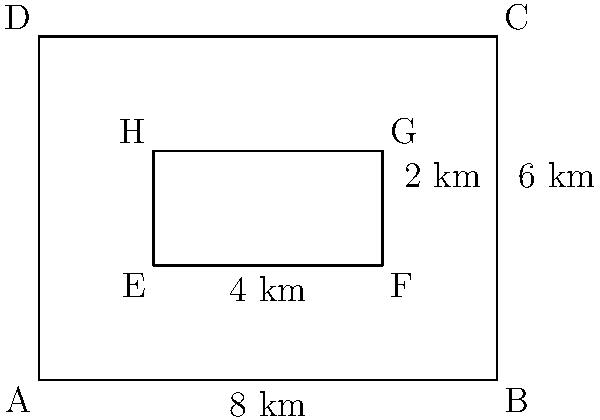As the alpha snow leopard, you need to calculate the area of your territory. The outer rectangle ABCD represents the entire region, while the inner rectangle EFGH represents a lake that is not part of your territory. If AB = 8 km, BC = 6 km, EF = 4 km, and FG = 2 km, what is the area of your territory in square kilometers? To find the area of the snow leopard's territory, we need to:

1. Calculate the area of the entire region (rectangle ABCD):
   Area of ABCD = $AB \times BC = 8 \text{ km} \times 6 \text{ km} = 48 \text{ km}^2$

2. Calculate the area of the lake (rectangle EFGH):
   Area of EFGH = $EF \times FG = 4 \text{ km} \times 2 \text{ km} = 8 \text{ km}^2$

3. Subtract the area of the lake from the area of the entire region:
   Territory area = Area of ABCD - Area of EFGH
   $= 48 \text{ km}^2 - 8 \text{ km}^2 = 40 \text{ km}^2$

Therefore, the area of the snow leopard's territory is $40 \text{ km}^2$.
Answer: $40 \text{ km}^2$ 